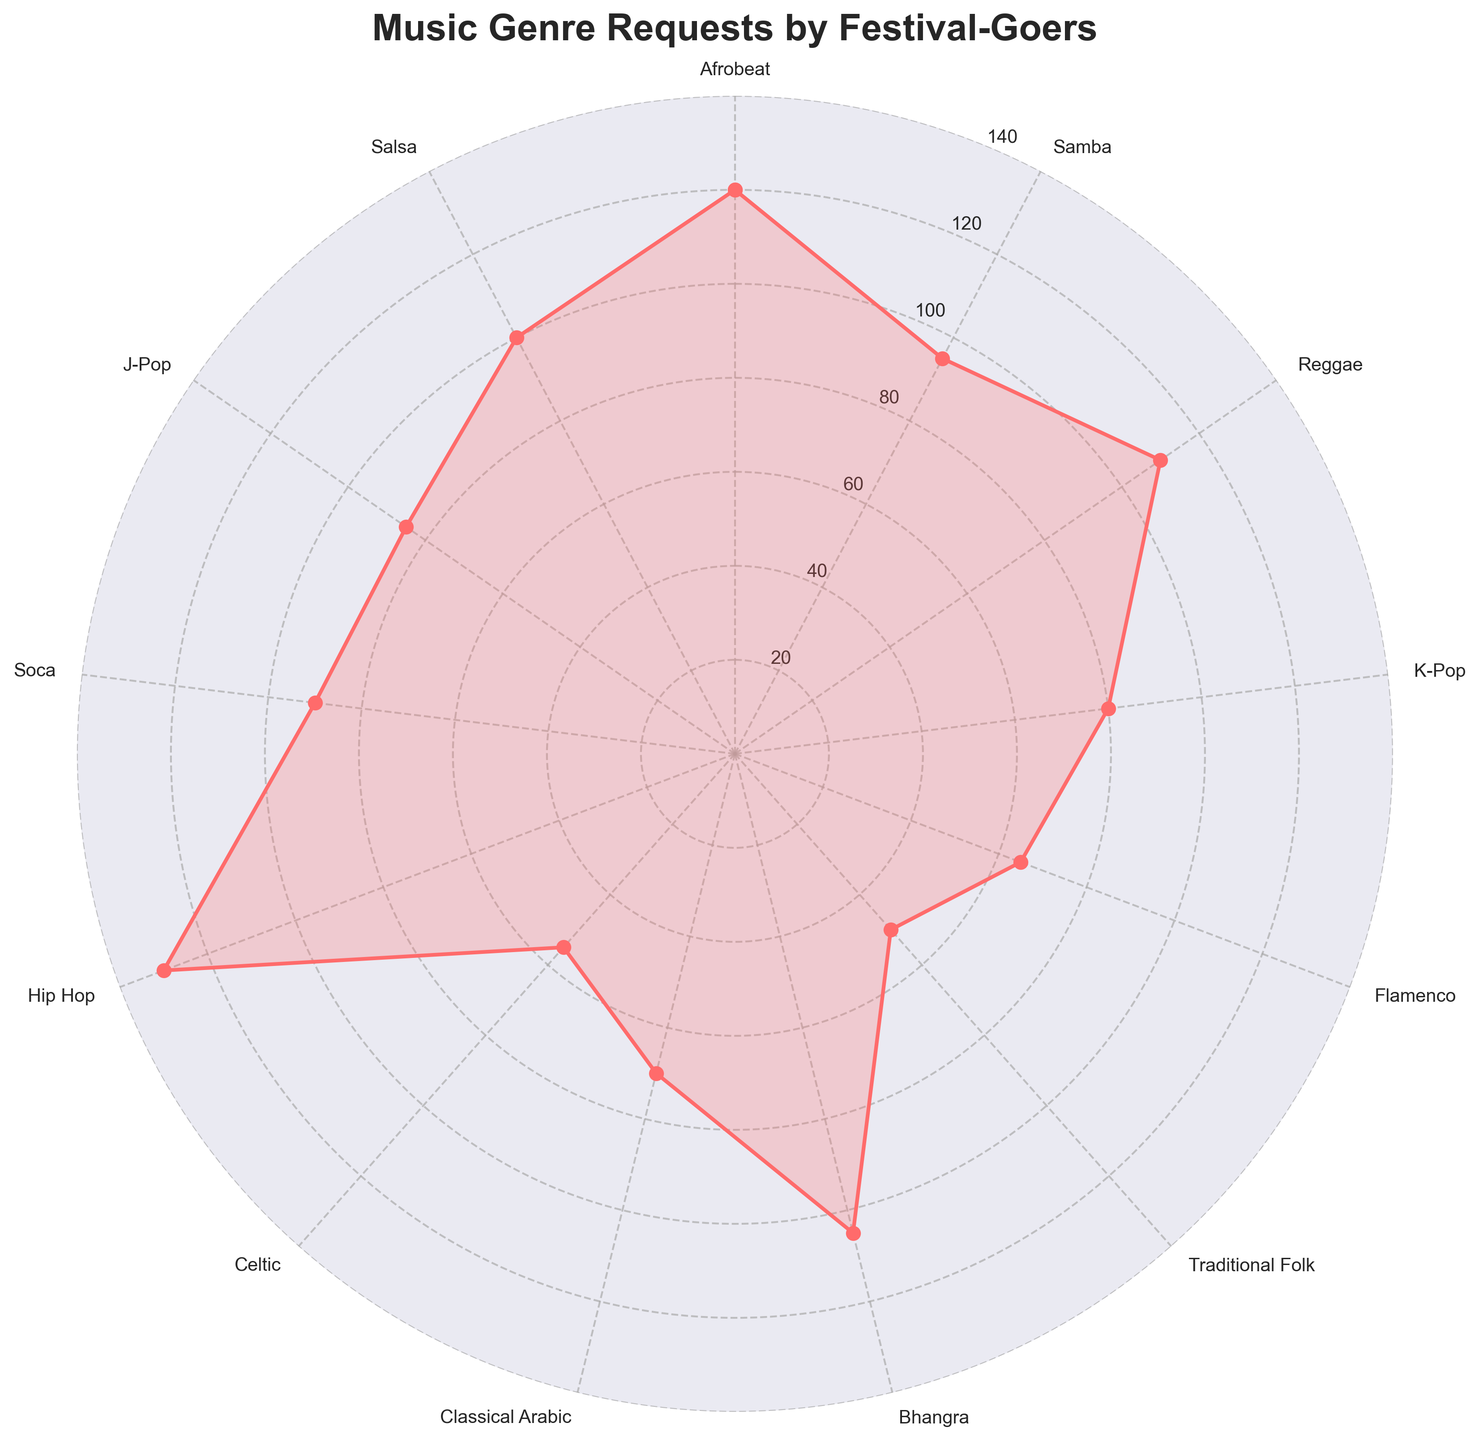What is the title of the plot? The title of the plot is usually displayed at the top of the figure. In this case, it indicates the overall theme or focus of the chart.
Answer: Music Genre Requests by Festival-Goers Which genre has the highest number of requests? To find the genre with the highest requests, look for the data point furthest from the center of the radar chart.
Answer: Hip Hop How many genres are represented in the radar chart? Count the individual points or labels around the chart. Each label represents a different genre.
Answer: 13 What is the lowest number of requests for any genre? Look for the data point that is closest to the center, which signifies the lowest value.
Answer: 50 (Traditional Folk) Which cultural background requested 'Salsa' the most? Identify the position of 'Salsa' on the radar chart and check the corresponding label for the cultural background.
Answer: South American Sum of requests for Afrobeat and Reggae Locate the data points for Afrobeat and Reggae and sum their values: 120 (Afrobeat) + 110 (Reggae).
Answer: 230 Is there any genre with exactly 100 requests? Check the data points for each genre to see if one falls exactly on the line corresponding to 100 requests.
Answer: Yes, Salsa How do requests for 'K-Pop' and 'J-Pop' compare? Compare the data points for 'K-Pop' and 'J-Pop' to see which is higher. K-Pop has 80 requests, while J-Pop has 85.
Answer: J-Pop has more requests Average number of requests across all genres Sum all the requests and divide by the number of genres: (120 + 95 + 110 + 80 + 65 + 50 + 105 + 70 + 55 + 130 + 90 + 85 + 100) / 13.
Answer: 89.23 